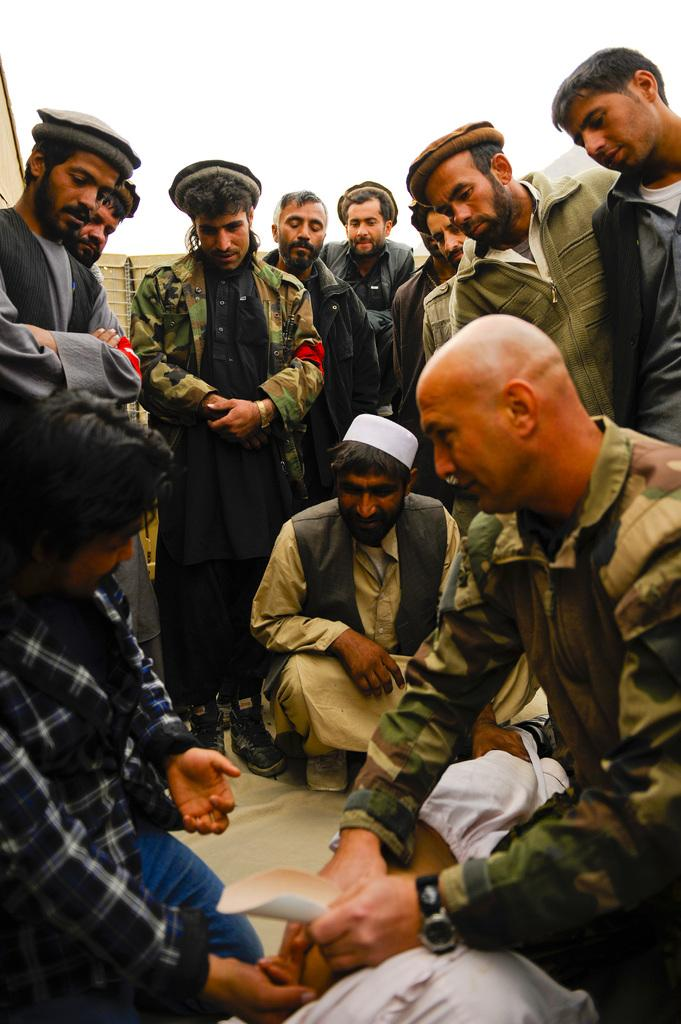How many persons are sitting on their legs in the image? There are three persons sitting on their legs in the image. What are the other persons in the image doing? There are a few persons standing around them. What color are the boys' eyes in the image? There is no mention of boys in the image, so we cannot determine the color of their eyes. 